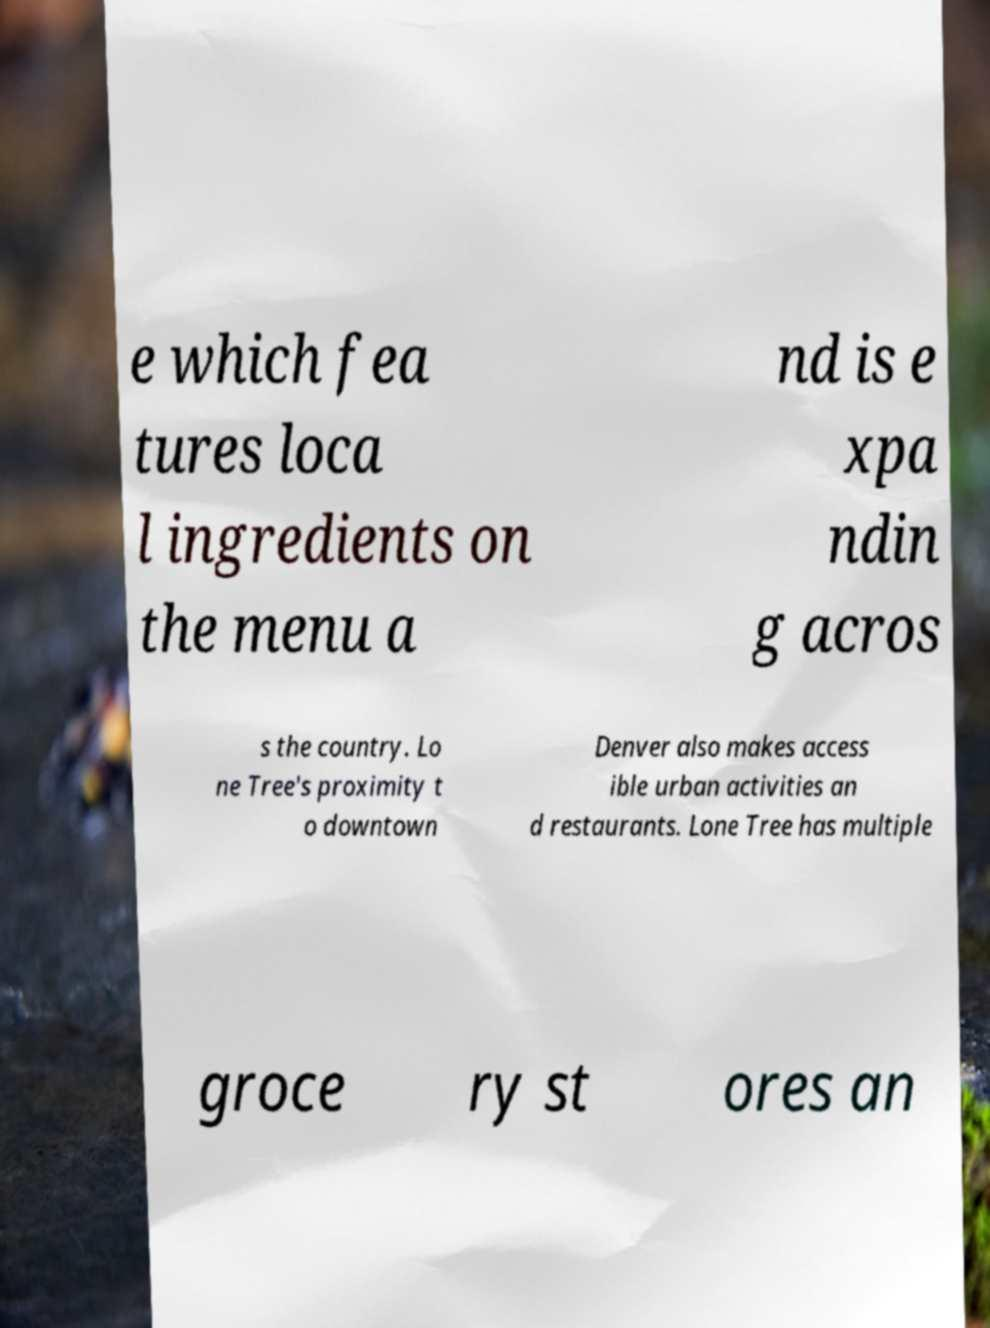What messages or text are displayed in this image? I need them in a readable, typed format. e which fea tures loca l ingredients on the menu a nd is e xpa ndin g acros s the country. Lo ne Tree's proximity t o downtown Denver also makes access ible urban activities an d restaurants. Lone Tree has multiple groce ry st ores an 